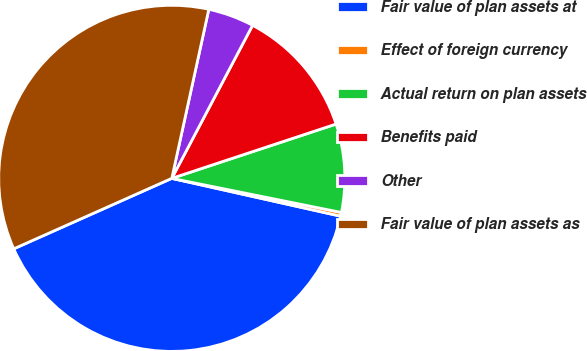Convert chart. <chart><loc_0><loc_0><loc_500><loc_500><pie_chart><fcel>Fair value of plan assets at<fcel>Effect of foreign currency<fcel>Actual return on plan assets<fcel>Benefits paid<fcel>Other<fcel>Fair value of plan assets as<nl><fcel>39.82%<fcel>0.35%<fcel>8.24%<fcel>12.19%<fcel>4.3%<fcel>35.11%<nl></chart> 